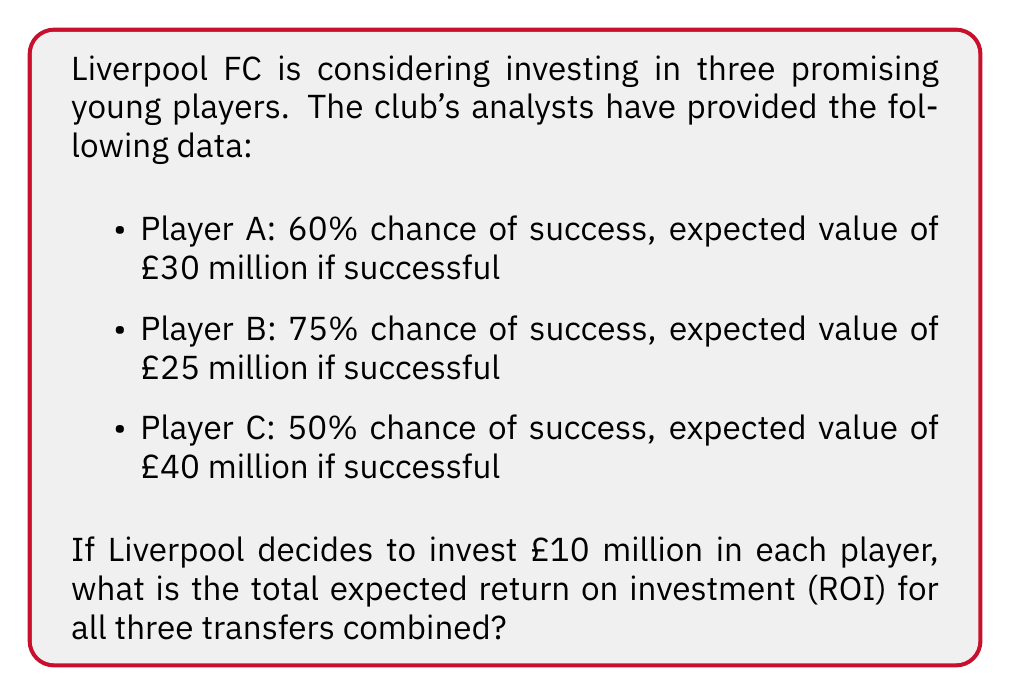Can you solve this math problem? To solve this problem, we need to follow these steps:

1. Calculate the expected value for each player:
   Player A: $E_A = 0.60 \times £30M = £18M$
   Player B: $E_B = 0.75 \times £25M = £18.75M$
   Player C: $E_C = 0.50 \times £40M = £20M$

2. Calculate the total expected value:
   $E_{total} = E_A + E_B + E_C = £18M + £18.75M + £20M = £56.75M$

3. Calculate the total investment:
   $I_{total} = £10M \times 3 = £30M$

4. Calculate the expected return:
   $R_{expected} = E_{total} - I_{total} = £56.75M - £30M = £26.75M$

5. Calculate the ROI:
   $$ROI = \frac{R_{expected}}{I_{total}} \times 100\%$$
   $$ROI = \frac{£26.75M}{£30M} \times 100\% = 0.8917 \times 100\% = 89.17\%$$

Therefore, the total expected ROI for all three transfers combined is 89.17%.
Answer: 89.17% 